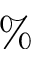Convert formula to latex. <formula><loc_0><loc_0><loc_500><loc_500>\%</formula> 